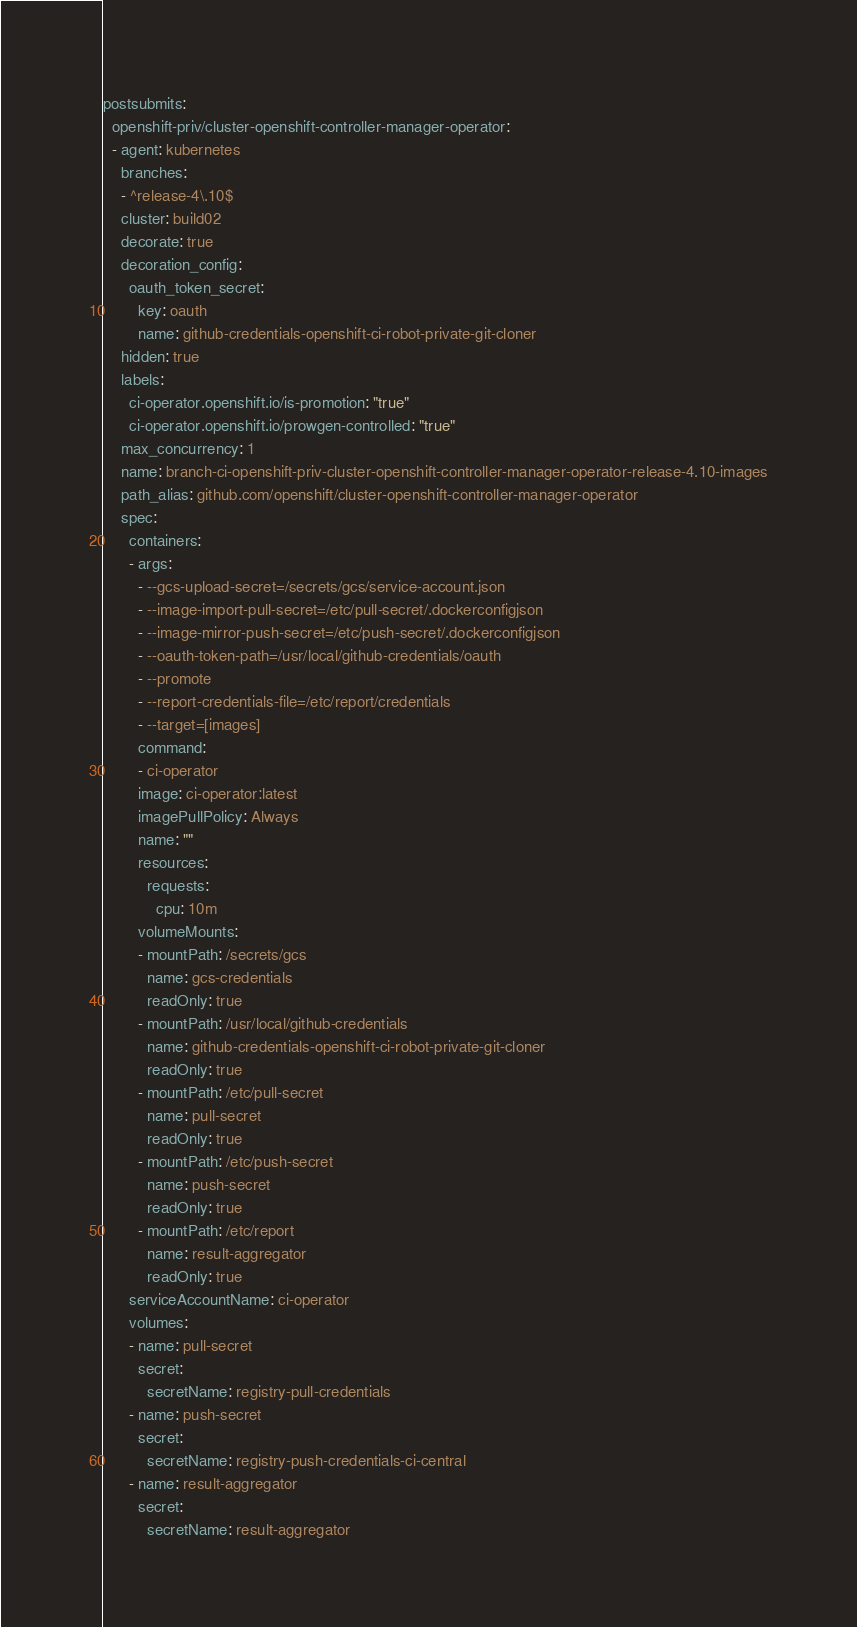Convert code to text. <code><loc_0><loc_0><loc_500><loc_500><_YAML_>postsubmits:
  openshift-priv/cluster-openshift-controller-manager-operator:
  - agent: kubernetes
    branches:
    - ^release-4\.10$
    cluster: build02
    decorate: true
    decoration_config:
      oauth_token_secret:
        key: oauth
        name: github-credentials-openshift-ci-robot-private-git-cloner
    hidden: true
    labels:
      ci-operator.openshift.io/is-promotion: "true"
      ci-operator.openshift.io/prowgen-controlled: "true"
    max_concurrency: 1
    name: branch-ci-openshift-priv-cluster-openshift-controller-manager-operator-release-4.10-images
    path_alias: github.com/openshift/cluster-openshift-controller-manager-operator
    spec:
      containers:
      - args:
        - --gcs-upload-secret=/secrets/gcs/service-account.json
        - --image-import-pull-secret=/etc/pull-secret/.dockerconfigjson
        - --image-mirror-push-secret=/etc/push-secret/.dockerconfigjson
        - --oauth-token-path=/usr/local/github-credentials/oauth
        - --promote
        - --report-credentials-file=/etc/report/credentials
        - --target=[images]
        command:
        - ci-operator
        image: ci-operator:latest
        imagePullPolicy: Always
        name: ""
        resources:
          requests:
            cpu: 10m
        volumeMounts:
        - mountPath: /secrets/gcs
          name: gcs-credentials
          readOnly: true
        - mountPath: /usr/local/github-credentials
          name: github-credentials-openshift-ci-robot-private-git-cloner
          readOnly: true
        - mountPath: /etc/pull-secret
          name: pull-secret
          readOnly: true
        - mountPath: /etc/push-secret
          name: push-secret
          readOnly: true
        - mountPath: /etc/report
          name: result-aggregator
          readOnly: true
      serviceAccountName: ci-operator
      volumes:
      - name: pull-secret
        secret:
          secretName: registry-pull-credentials
      - name: push-secret
        secret:
          secretName: registry-push-credentials-ci-central
      - name: result-aggregator
        secret:
          secretName: result-aggregator
</code> 